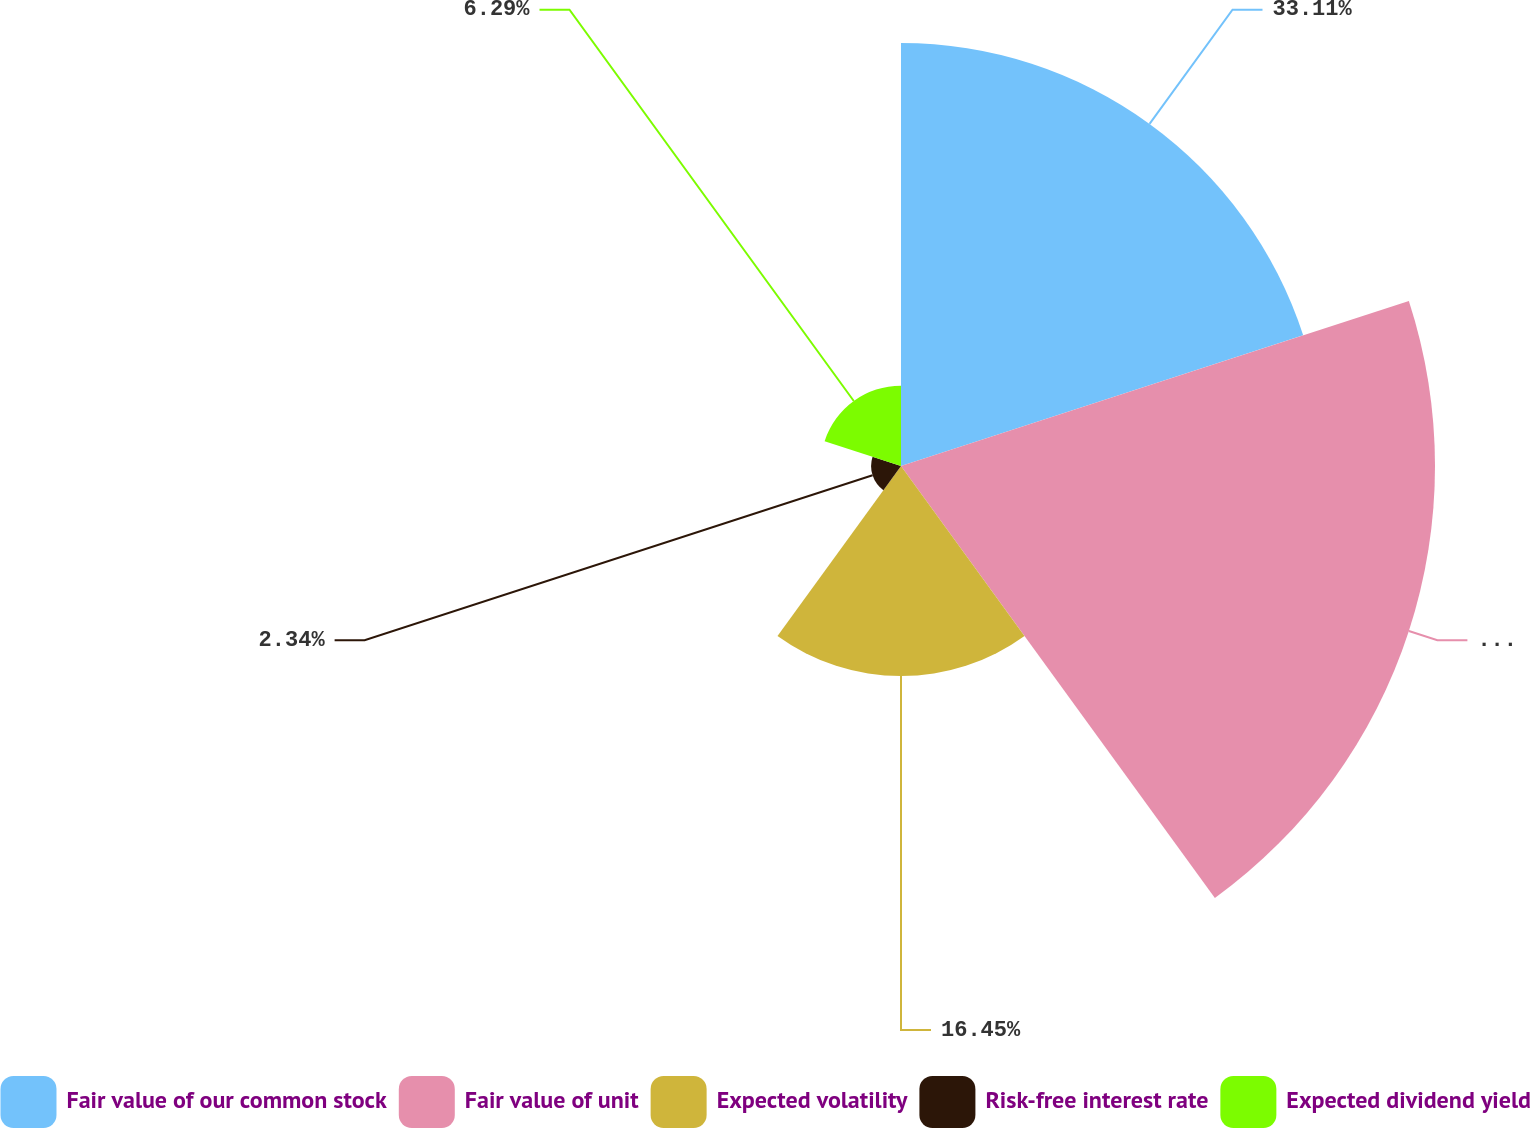<chart> <loc_0><loc_0><loc_500><loc_500><pie_chart><fcel>Fair value of our common stock<fcel>Fair value of unit<fcel>Expected volatility<fcel>Risk-free interest rate<fcel>Expected dividend yield<nl><fcel>33.11%<fcel>41.81%<fcel>16.45%<fcel>2.34%<fcel>6.29%<nl></chart> 